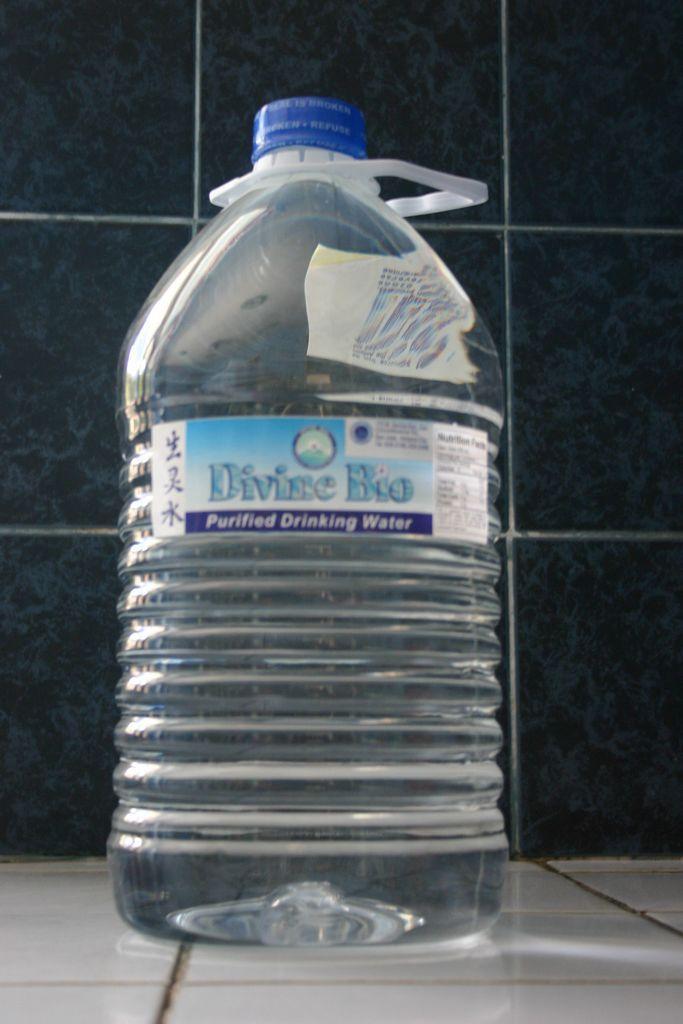In one or two sentences, can you explain what this image depicts? This picture is clicked inside a room. Here, we see water bottle which is placed on the floor. The lid of this bottle is blue in color. We can see some text written on the paper which is pasted on the bottle. The text is divine bio purified drinking water. 